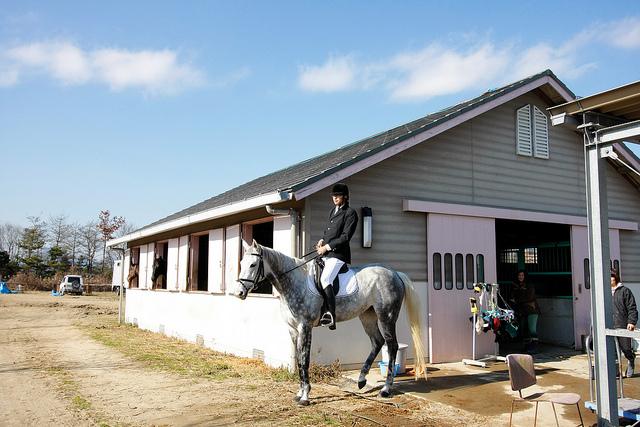What color is the horse?
Concise answer only. Gray. Is there a cow in this picture?
Give a very brief answer. No. Where was this photo taken?
Write a very short answer. Stables. Is someone on the horse?
Write a very short answer. Yes. 